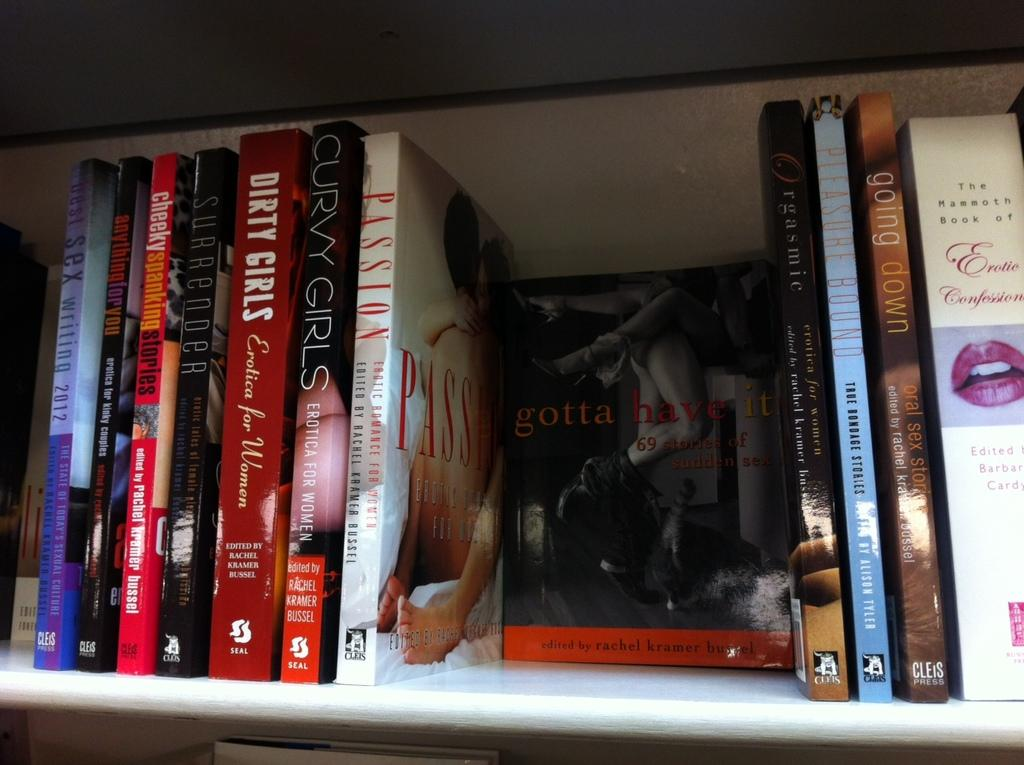<image>
Write a terse but informative summary of the picture. A selection of sexually themed books such as one titled Dirty Girls are stacked on a shelf. 